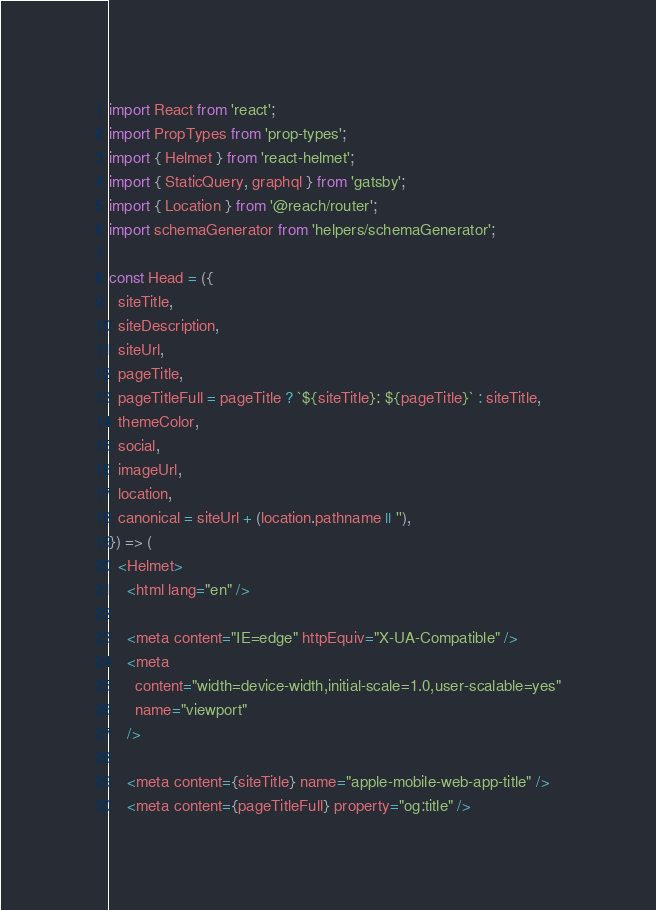<code> <loc_0><loc_0><loc_500><loc_500><_JavaScript_>import React from 'react';
import PropTypes from 'prop-types';
import { Helmet } from 'react-helmet';
import { StaticQuery, graphql } from 'gatsby';
import { Location } from '@reach/router';
import schemaGenerator from 'helpers/schemaGenerator';

const Head = ({
  siteTitle,
  siteDescription,
  siteUrl,
  pageTitle,
  pageTitleFull = pageTitle ? `${siteTitle}: ${pageTitle}` : siteTitle,
  themeColor,
  social,
  imageUrl,
  location,
  canonical = siteUrl + (location.pathname || ''),
}) => (
  <Helmet>
    <html lang="en" />

    <meta content="IE=edge" httpEquiv="X-UA-Compatible" />
    <meta
      content="width=device-width,initial-scale=1.0,user-scalable=yes"
      name="viewport"
    />

    <meta content={siteTitle} name="apple-mobile-web-app-title" />
    <meta content={pageTitleFull} property="og:title" /></code> 